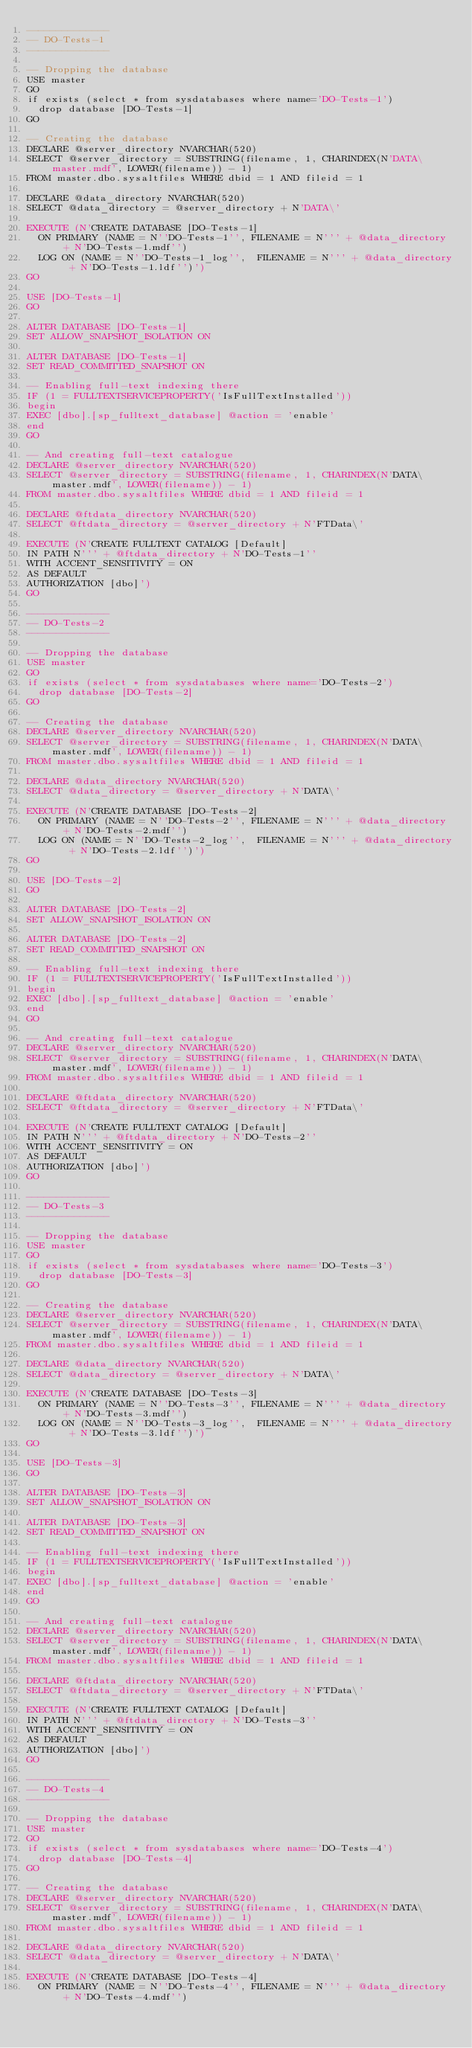Convert code to text. <code><loc_0><loc_0><loc_500><loc_500><_SQL_>--------------
-- DO-Tests-1
--------------

-- Dropping the database
USE master
GO
if exists (select * from sysdatabases where name='DO-Tests-1')
  drop database [DO-Tests-1]
GO

-- Creating the database
DECLARE @server_directory NVARCHAR(520)
SELECT @server_directory = SUBSTRING(filename, 1, CHARINDEX(N'DATA\master.mdf', LOWER(filename)) - 1)
FROM master.dbo.sysaltfiles WHERE dbid = 1 AND fileid = 1

DECLARE @data_directory NVARCHAR(520)
SELECT @data_directory = @server_directory + N'DATA\'

EXECUTE (N'CREATE DATABASE [DO-Tests-1]
  ON PRIMARY (NAME = N''DO-Tests-1'', FILENAME = N''' + @data_directory + N'DO-Tests-1.mdf'')
  LOG ON (NAME = N''DO-Tests-1_log'',  FILENAME = N''' + @data_directory + N'DO-Tests-1.ldf'')')
GO

USE [DO-Tests-1]
GO

ALTER DATABASE [DO-Tests-1]
SET ALLOW_SNAPSHOT_ISOLATION ON

ALTER DATABASE [DO-Tests-1]
SET READ_COMMITTED_SNAPSHOT ON

-- Enabling full-text indexing there
IF (1 = FULLTEXTSERVICEPROPERTY('IsFullTextInstalled'))
begin
EXEC [dbo].[sp_fulltext_database] @action = 'enable'
end
GO

-- And creating full-text catalogue
DECLARE @server_directory NVARCHAR(520)
SELECT @server_directory = SUBSTRING(filename, 1, CHARINDEX(N'DATA\master.mdf', LOWER(filename)) - 1)
FROM master.dbo.sysaltfiles WHERE dbid = 1 AND fileid = 1

DECLARE @ftdata_directory NVARCHAR(520)
SELECT @ftdata_directory = @server_directory + N'FTData\'

EXECUTE (N'CREATE FULLTEXT CATALOG [Default]
IN PATH N''' + @ftdata_directory + N'DO-Tests-1''
WITH ACCENT_SENSITIVITY = ON
AS DEFAULT
AUTHORIZATION [dbo]')
GO

--------------
-- DO-Tests-2
--------------

-- Dropping the database
USE master
GO
if exists (select * from sysdatabases where name='DO-Tests-2')
  drop database [DO-Tests-2]
GO

-- Creating the database
DECLARE @server_directory NVARCHAR(520)
SELECT @server_directory = SUBSTRING(filename, 1, CHARINDEX(N'DATA\master.mdf', LOWER(filename)) - 1)
FROM master.dbo.sysaltfiles WHERE dbid = 1 AND fileid = 1

DECLARE @data_directory NVARCHAR(520)
SELECT @data_directory = @server_directory + N'DATA\'

EXECUTE (N'CREATE DATABASE [DO-Tests-2]
  ON PRIMARY (NAME = N''DO-Tests-2'', FILENAME = N''' + @data_directory + N'DO-Tests-2.mdf'')
  LOG ON (NAME = N''DO-Tests-2_log'',  FILENAME = N''' + @data_directory + N'DO-Tests-2.ldf'')')
GO

USE [DO-Tests-2]
GO

ALTER DATABASE [DO-Tests-2]
SET ALLOW_SNAPSHOT_ISOLATION ON

ALTER DATABASE [DO-Tests-2]
SET READ_COMMITTED_SNAPSHOT ON

-- Enabling full-text indexing there
IF (1 = FULLTEXTSERVICEPROPERTY('IsFullTextInstalled'))
begin
EXEC [dbo].[sp_fulltext_database] @action = 'enable'
end
GO

-- And creating full-text catalogue
DECLARE @server_directory NVARCHAR(520)
SELECT @server_directory = SUBSTRING(filename, 1, CHARINDEX(N'DATA\master.mdf', LOWER(filename)) - 1)
FROM master.dbo.sysaltfiles WHERE dbid = 1 AND fileid = 1

DECLARE @ftdata_directory NVARCHAR(520)
SELECT @ftdata_directory = @server_directory + N'FTData\'

EXECUTE (N'CREATE FULLTEXT CATALOG [Default]
IN PATH N''' + @ftdata_directory + N'DO-Tests-2''
WITH ACCENT_SENSITIVITY = ON
AS DEFAULT
AUTHORIZATION [dbo]')
GO

--------------
-- DO-Tests-3
--------------

-- Dropping the database
USE master
GO
if exists (select * from sysdatabases where name='DO-Tests-3')
  drop database [DO-Tests-3]
GO

-- Creating the database
DECLARE @server_directory NVARCHAR(520)
SELECT @server_directory = SUBSTRING(filename, 1, CHARINDEX(N'DATA\master.mdf', LOWER(filename)) - 1)
FROM master.dbo.sysaltfiles WHERE dbid = 1 AND fileid = 1

DECLARE @data_directory NVARCHAR(520)
SELECT @data_directory = @server_directory + N'DATA\'

EXECUTE (N'CREATE DATABASE [DO-Tests-3]
  ON PRIMARY (NAME = N''DO-Tests-3'', FILENAME = N''' + @data_directory + N'DO-Tests-3.mdf'')
  LOG ON (NAME = N''DO-Tests-3_log'',  FILENAME = N''' + @data_directory + N'DO-Tests-3.ldf'')')
GO

USE [DO-Tests-3]
GO

ALTER DATABASE [DO-Tests-3]
SET ALLOW_SNAPSHOT_ISOLATION ON

ALTER DATABASE [DO-Tests-3]
SET READ_COMMITTED_SNAPSHOT ON

-- Enabling full-text indexing there
IF (1 = FULLTEXTSERVICEPROPERTY('IsFullTextInstalled'))
begin
EXEC [dbo].[sp_fulltext_database] @action = 'enable'
end
GO

-- And creating full-text catalogue
DECLARE @server_directory NVARCHAR(520)
SELECT @server_directory = SUBSTRING(filename, 1, CHARINDEX(N'DATA\master.mdf', LOWER(filename)) - 1)
FROM master.dbo.sysaltfiles WHERE dbid = 1 AND fileid = 1

DECLARE @ftdata_directory NVARCHAR(520)
SELECT @ftdata_directory = @server_directory + N'FTData\'

EXECUTE (N'CREATE FULLTEXT CATALOG [Default]
IN PATH N''' + @ftdata_directory + N'DO-Tests-3''
WITH ACCENT_SENSITIVITY = ON
AS DEFAULT
AUTHORIZATION [dbo]')
GO

--------------
-- DO-Tests-4
--------------

-- Dropping the database
USE master
GO
if exists (select * from sysdatabases where name='DO-Tests-4')
  drop database [DO-Tests-4]
GO

-- Creating the database
DECLARE @server_directory NVARCHAR(520)
SELECT @server_directory = SUBSTRING(filename, 1, CHARINDEX(N'DATA\master.mdf', LOWER(filename)) - 1)
FROM master.dbo.sysaltfiles WHERE dbid = 1 AND fileid = 1

DECLARE @data_directory NVARCHAR(520)
SELECT @data_directory = @server_directory + N'DATA\'

EXECUTE (N'CREATE DATABASE [DO-Tests-4]
  ON PRIMARY (NAME = N''DO-Tests-4'', FILENAME = N''' + @data_directory + N'DO-Tests-4.mdf'')</code> 